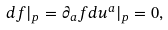Convert formula to latex. <formula><loc_0><loc_0><loc_500><loc_500>d f | _ { p } = \partial _ { a } f d u ^ { a } | _ { p } = 0 ,</formula> 